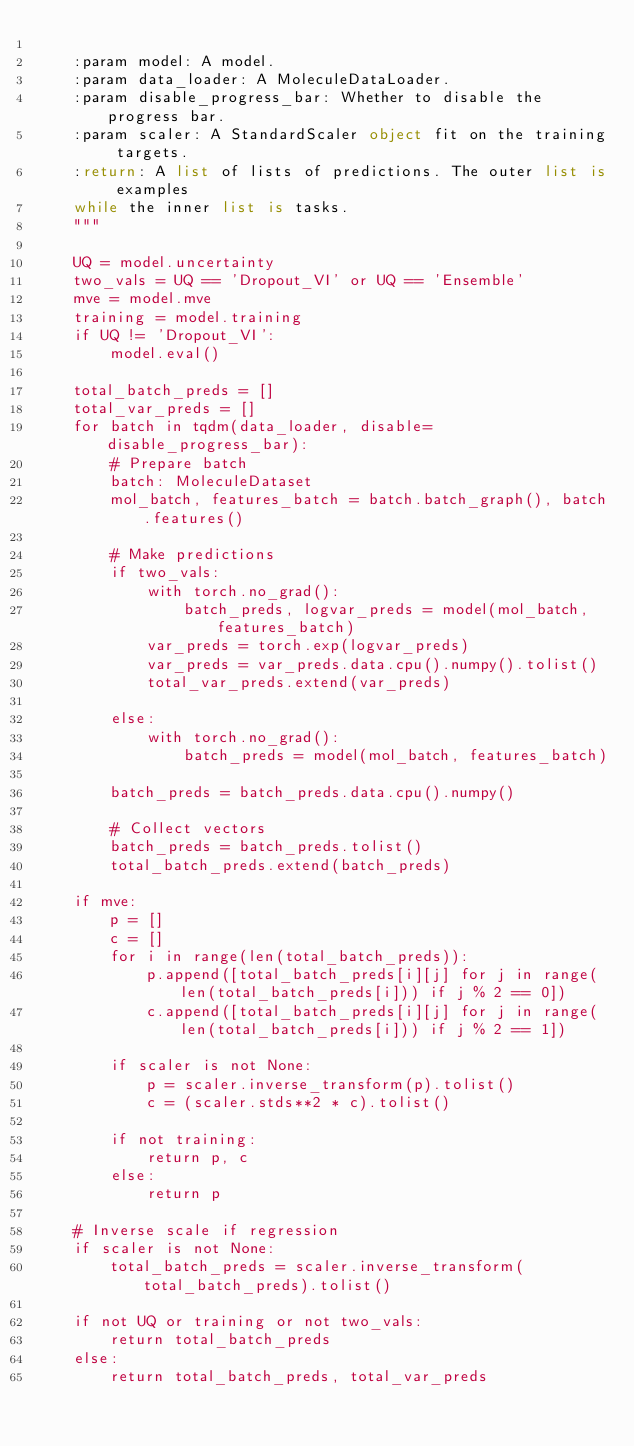<code> <loc_0><loc_0><loc_500><loc_500><_Python_>
    :param model: A model.
    :param data_loader: A MoleculeDataLoader.
    :param disable_progress_bar: Whether to disable the progress bar.
    :param scaler: A StandardScaler object fit on the training targets.
    :return: A list of lists of predictions. The outer list is examples
    while the inner list is tasks.
    """

    UQ = model.uncertainty
    two_vals = UQ == 'Dropout_VI' or UQ == 'Ensemble'
    mve = model.mve
    training = model.training
    if UQ != 'Dropout_VI':
        model.eval()

    total_batch_preds = []
    total_var_preds = []
    for batch in tqdm(data_loader, disable=disable_progress_bar):
        # Prepare batch
        batch: MoleculeDataset
        mol_batch, features_batch = batch.batch_graph(), batch.features()

        # Make predictions
        if two_vals:
            with torch.no_grad():
                batch_preds, logvar_preds = model(mol_batch, features_batch)
            var_preds = torch.exp(logvar_preds)
            var_preds = var_preds.data.cpu().numpy().tolist()
            total_var_preds.extend(var_preds)

        else:
            with torch.no_grad():
                batch_preds = model(mol_batch, features_batch)

        batch_preds = batch_preds.data.cpu().numpy()

        # Collect vectors
        batch_preds = batch_preds.tolist()
        total_batch_preds.extend(batch_preds)

    if mve:
        p = []
        c = []
        for i in range(len(total_batch_preds)):
            p.append([total_batch_preds[i][j] for j in range(len(total_batch_preds[i])) if j % 2 == 0])
            c.append([total_batch_preds[i][j] for j in range(len(total_batch_preds[i])) if j % 2 == 1])

        if scaler is not None:
            p = scaler.inverse_transform(p).tolist()
            c = (scaler.stds**2 * c).tolist()

        if not training:
            return p, c
        else:
            return p

    # Inverse scale if regression
    if scaler is not None:
        total_batch_preds = scaler.inverse_transform(total_batch_preds).tolist()

    if not UQ or training or not two_vals:
        return total_batch_preds
    else:
        return total_batch_preds, total_var_preds
</code> 